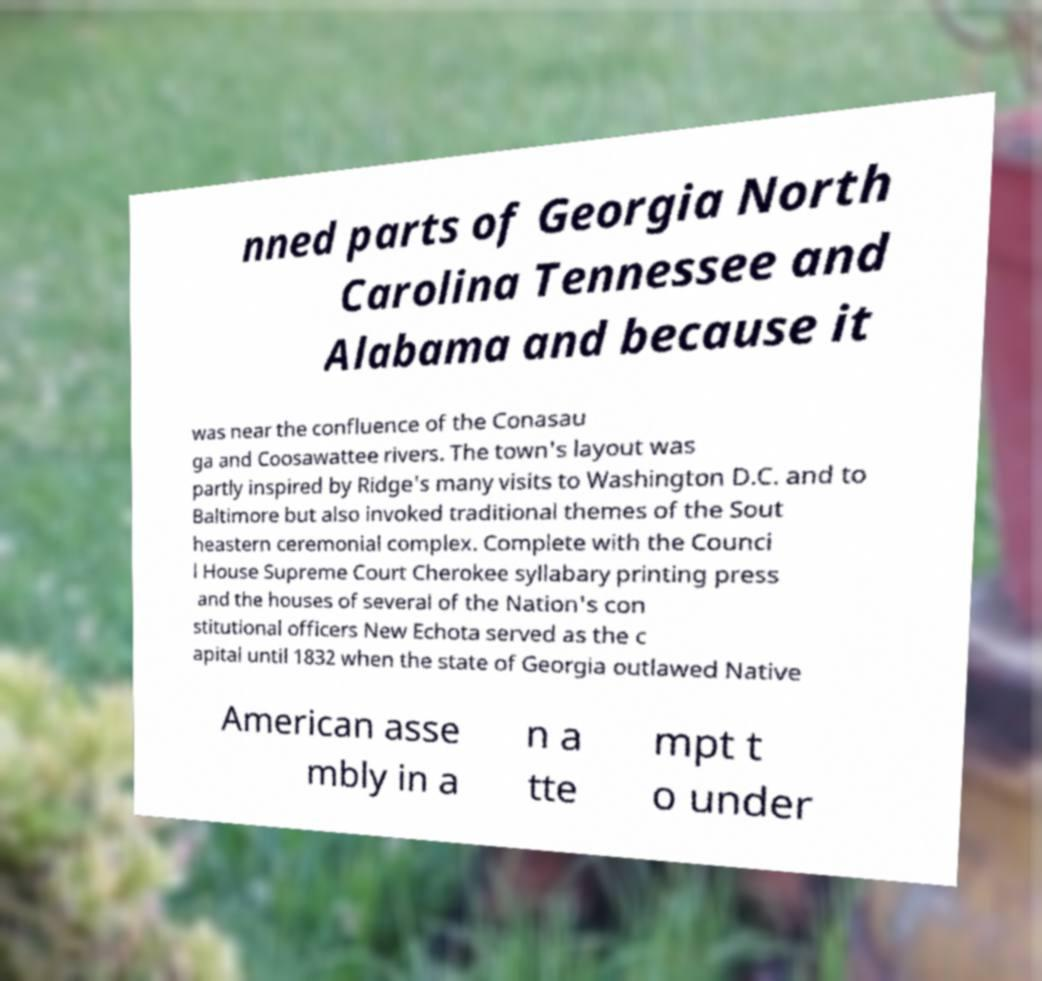There's text embedded in this image that I need extracted. Can you transcribe it verbatim? nned parts of Georgia North Carolina Tennessee and Alabama and because it was near the confluence of the Conasau ga and Coosawattee rivers. The town's layout was partly inspired by Ridge's many visits to Washington D.C. and to Baltimore but also invoked traditional themes of the Sout heastern ceremonial complex. Complete with the Counci l House Supreme Court Cherokee syllabary printing press and the houses of several of the Nation's con stitutional officers New Echota served as the c apital until 1832 when the state of Georgia outlawed Native American asse mbly in a n a tte mpt t o under 